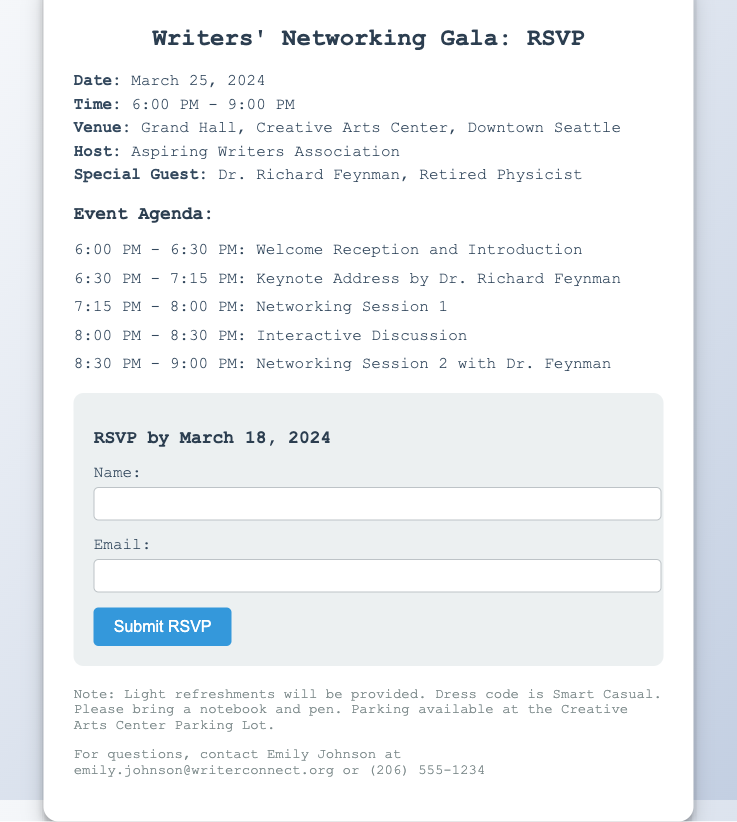What is the date of the event? The date of the event is specified in the event details section of the document as March 25, 2024.
Answer: March 25, 2024 Who is the special guest? The special guest is mentioned in the event details section as Dr. Richard Feynman.
Answer: Dr. Richard Feynman What time does the event start? The start time of the event is included in the details and is given as 6:00 PM.
Answer: 6:00 PM How many networking sessions are there? The document lists two networking sessions in the agenda which takes place at different intervals.
Answer: 2 What is the dress code for the event? The note section of the document mentions the dress code as Smart Casual.
Answer: Smart Casual What is the RSVP deadline? The RSVP deadline is stated clearly in the RSVP form section as March 18, 2024.
Answer: March 18, 2024 Which venue will host the gala? The venue for the gala is provided in the event details as Grand Hall, Creative Arts Center, Downtown Seattle.
Answer: Grand Hall, Creative Arts Center, Downtown Seattle What refreshments will be provided? The notes section mentions that light refreshments will be provided during the event.
Answer: Light refreshments 